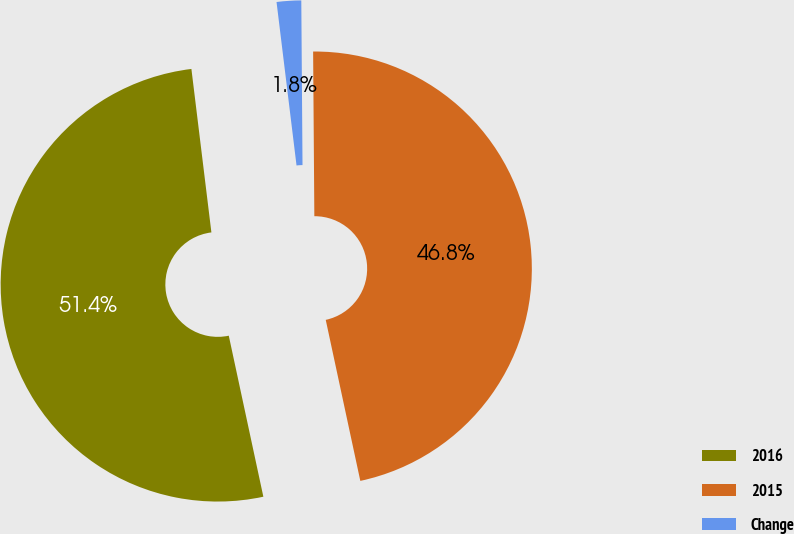<chart> <loc_0><loc_0><loc_500><loc_500><pie_chart><fcel>2016<fcel>2015<fcel>Change<nl><fcel>51.43%<fcel>46.75%<fcel>1.82%<nl></chart> 